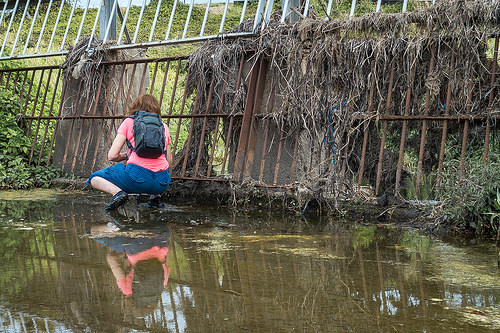<image>
Can you confirm if the water is on the women? No. The water is not positioned on the women. They may be near each other, but the water is not supported by or resting on top of the women. 